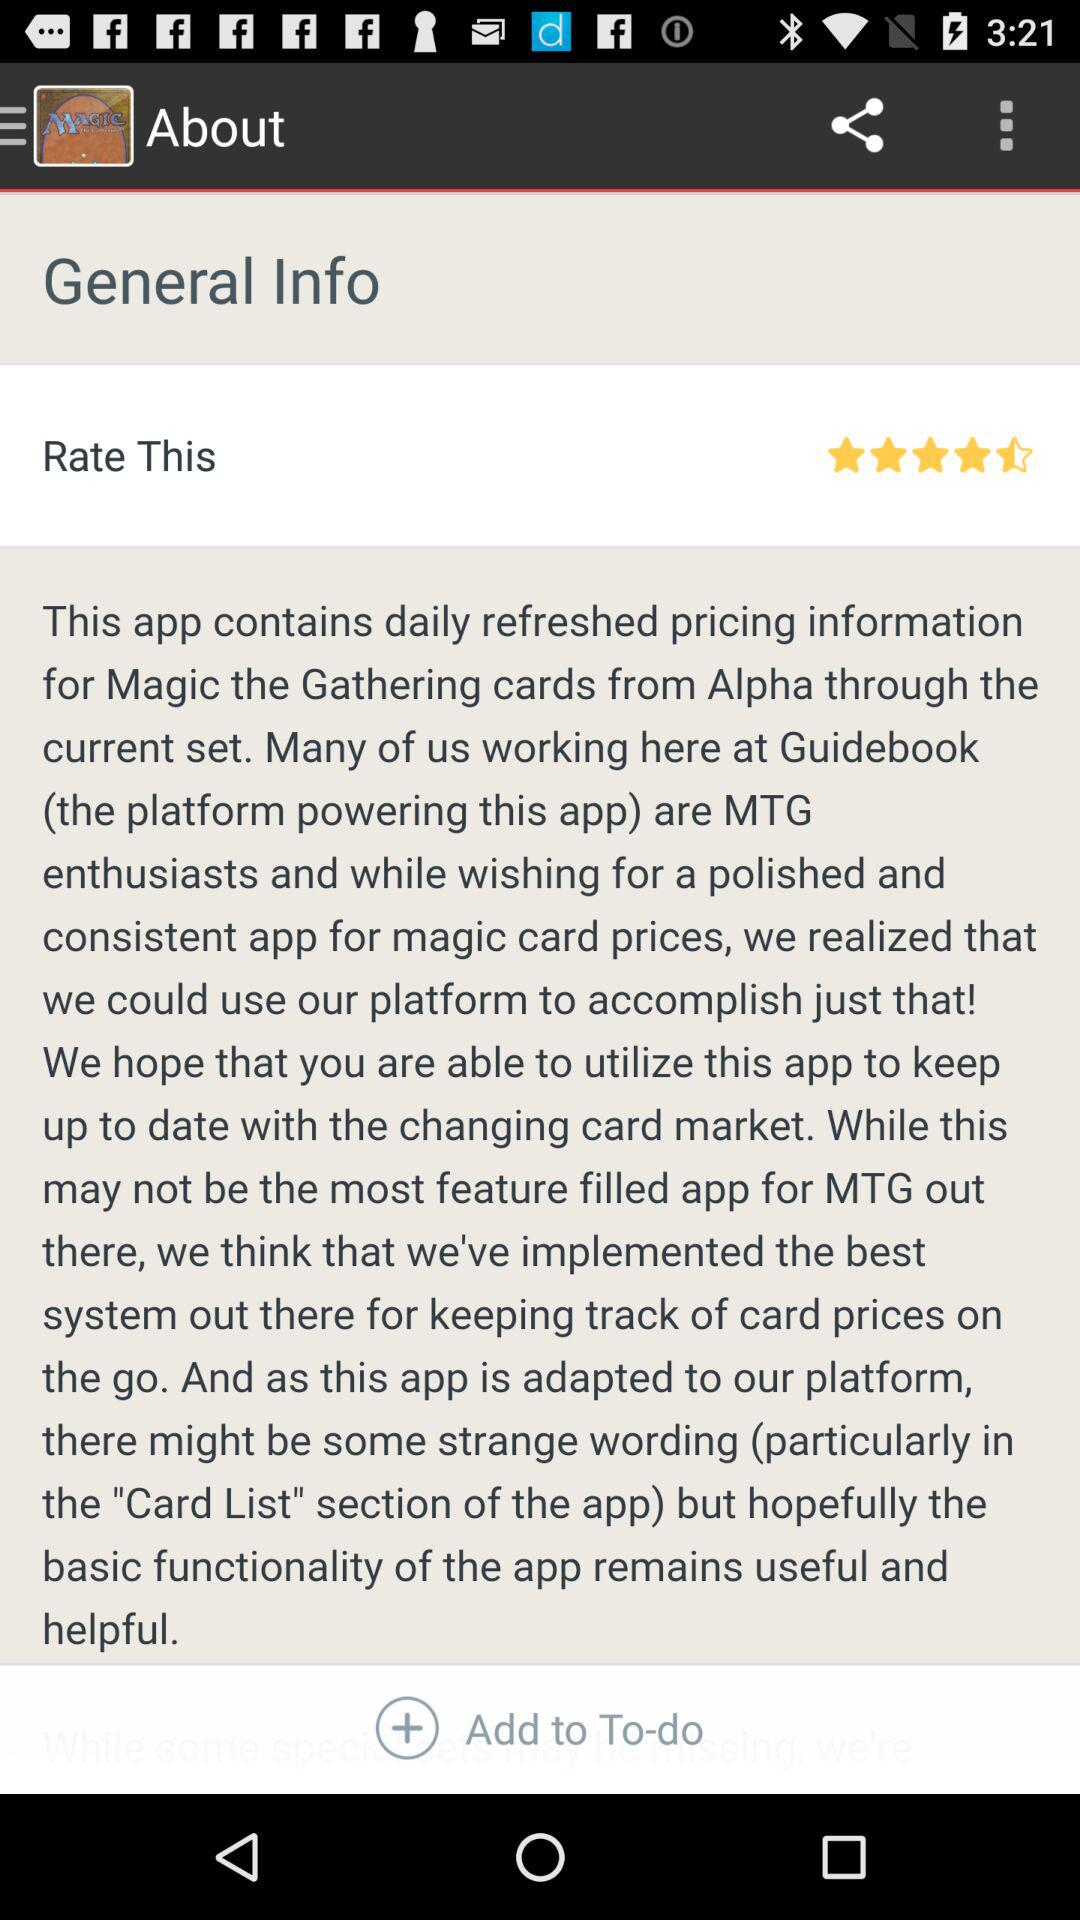What is the given rating? The given rating is 4.5 stars. 